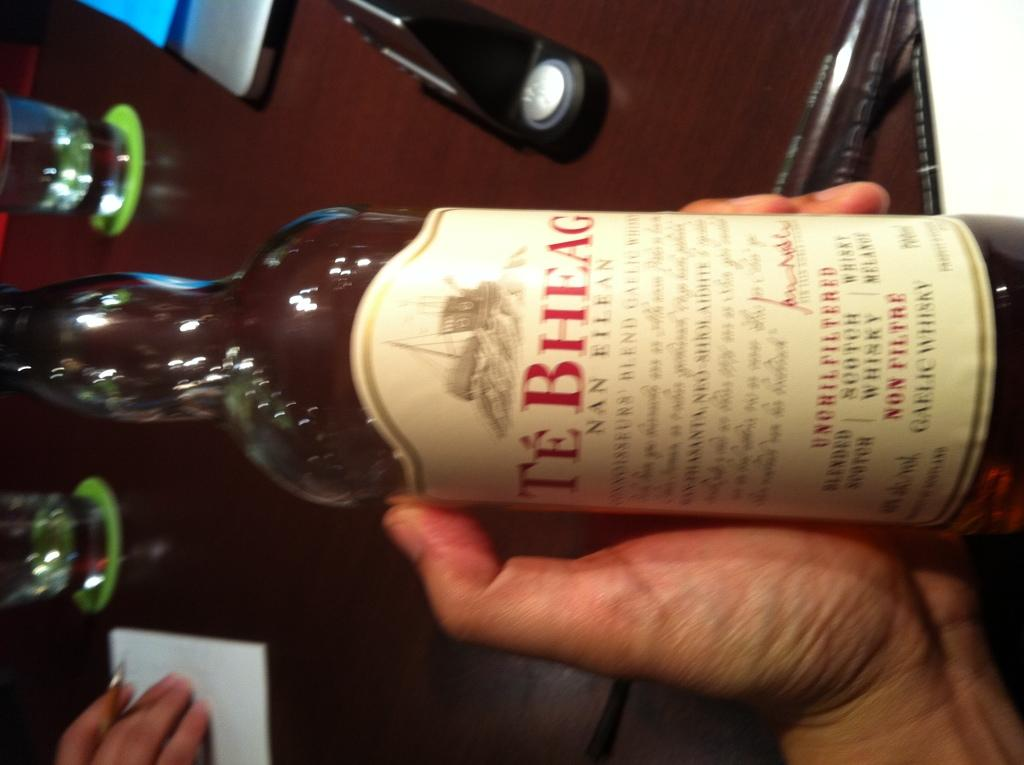<image>
Give a short and clear explanation of the subsequent image. Te Bheag is the name displayed on the label of this whiskey bottle. 